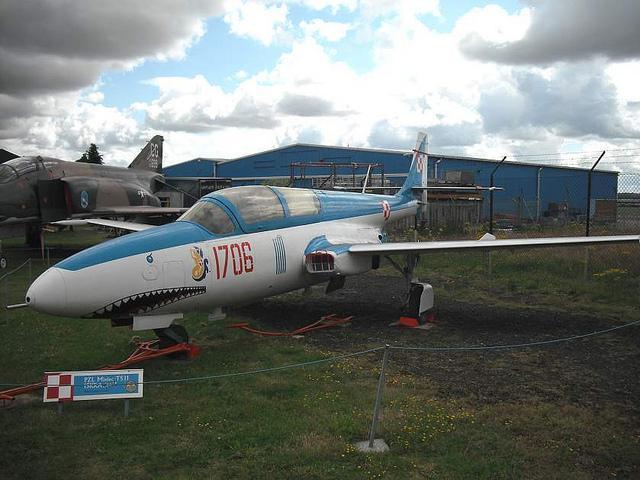How many airplanes are there?
Give a very brief answer. 2. How many people are in the picture?
Give a very brief answer. 0. 